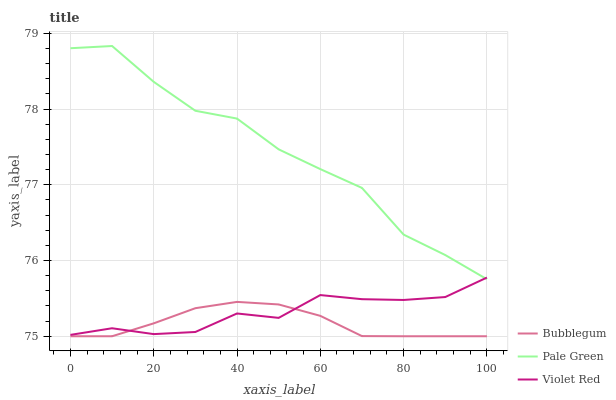Does Bubblegum have the minimum area under the curve?
Answer yes or no. Yes. Does Pale Green have the maximum area under the curve?
Answer yes or no. Yes. Does Pale Green have the minimum area under the curve?
Answer yes or no. No. Does Bubblegum have the maximum area under the curve?
Answer yes or no. No. Is Bubblegum the smoothest?
Answer yes or no. Yes. Is Pale Green the roughest?
Answer yes or no. Yes. Is Pale Green the smoothest?
Answer yes or no. No. Is Bubblegum the roughest?
Answer yes or no. No. Does Bubblegum have the lowest value?
Answer yes or no. Yes. Does Pale Green have the lowest value?
Answer yes or no. No. Does Pale Green have the highest value?
Answer yes or no. Yes. Does Bubblegum have the highest value?
Answer yes or no. No. Is Bubblegum less than Pale Green?
Answer yes or no. Yes. Is Pale Green greater than Bubblegum?
Answer yes or no. Yes. Does Violet Red intersect Bubblegum?
Answer yes or no. Yes. Is Violet Red less than Bubblegum?
Answer yes or no. No. Is Violet Red greater than Bubblegum?
Answer yes or no. No. Does Bubblegum intersect Pale Green?
Answer yes or no. No. 